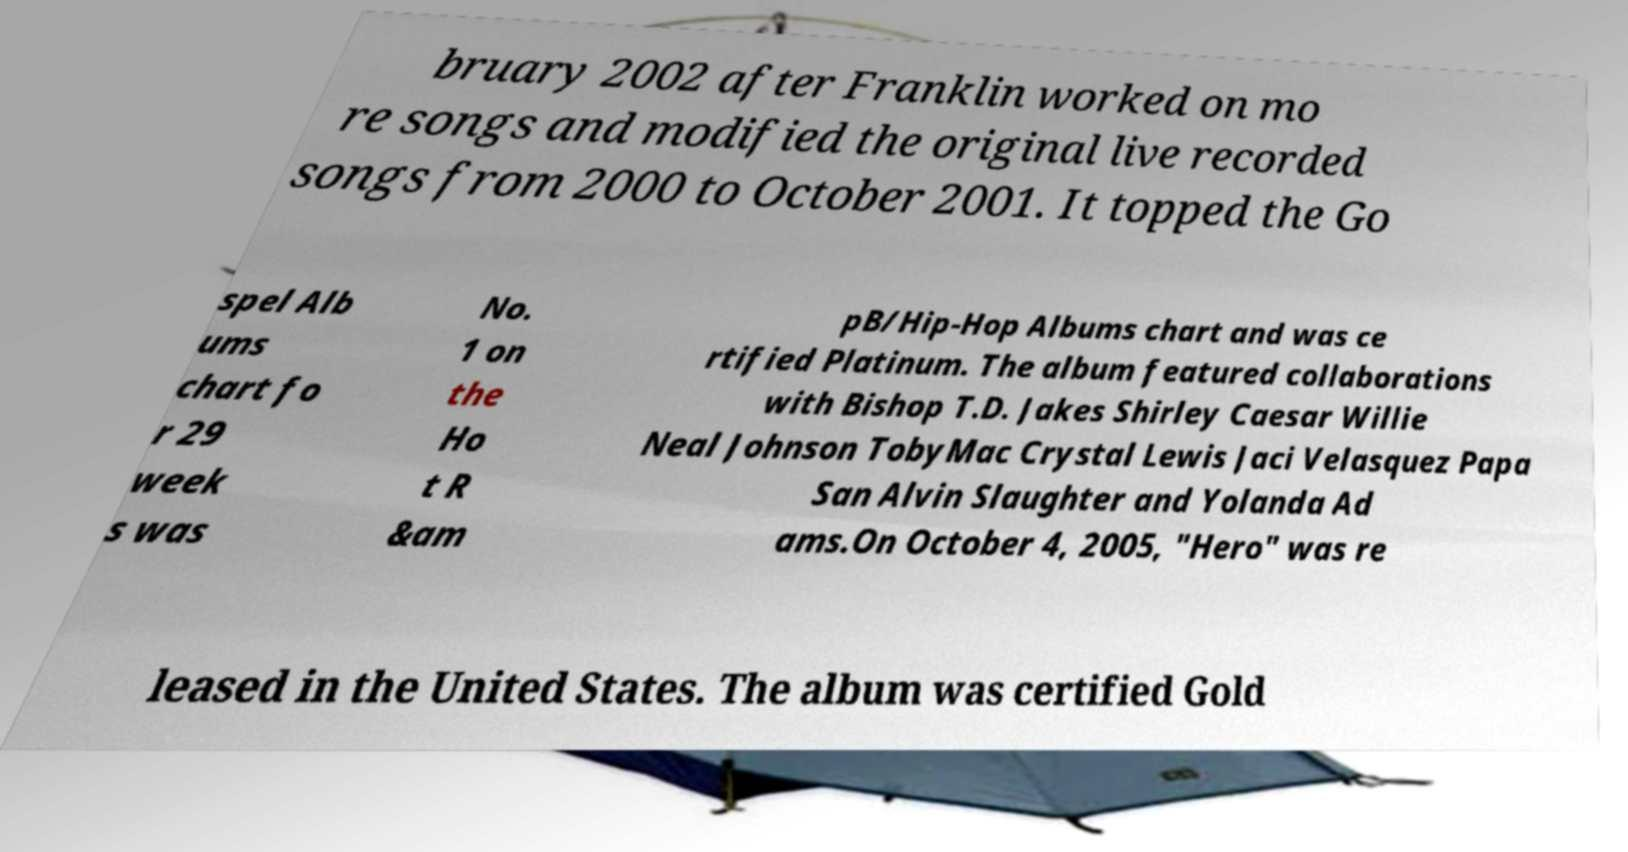Please identify and transcribe the text found in this image. bruary 2002 after Franklin worked on mo re songs and modified the original live recorded songs from 2000 to October 2001. It topped the Go spel Alb ums chart fo r 29 week s was No. 1 on the Ho t R &am pB/Hip-Hop Albums chart and was ce rtified Platinum. The album featured collaborations with Bishop T.D. Jakes Shirley Caesar Willie Neal Johnson TobyMac Crystal Lewis Jaci Velasquez Papa San Alvin Slaughter and Yolanda Ad ams.On October 4, 2005, "Hero" was re leased in the United States. The album was certified Gold 